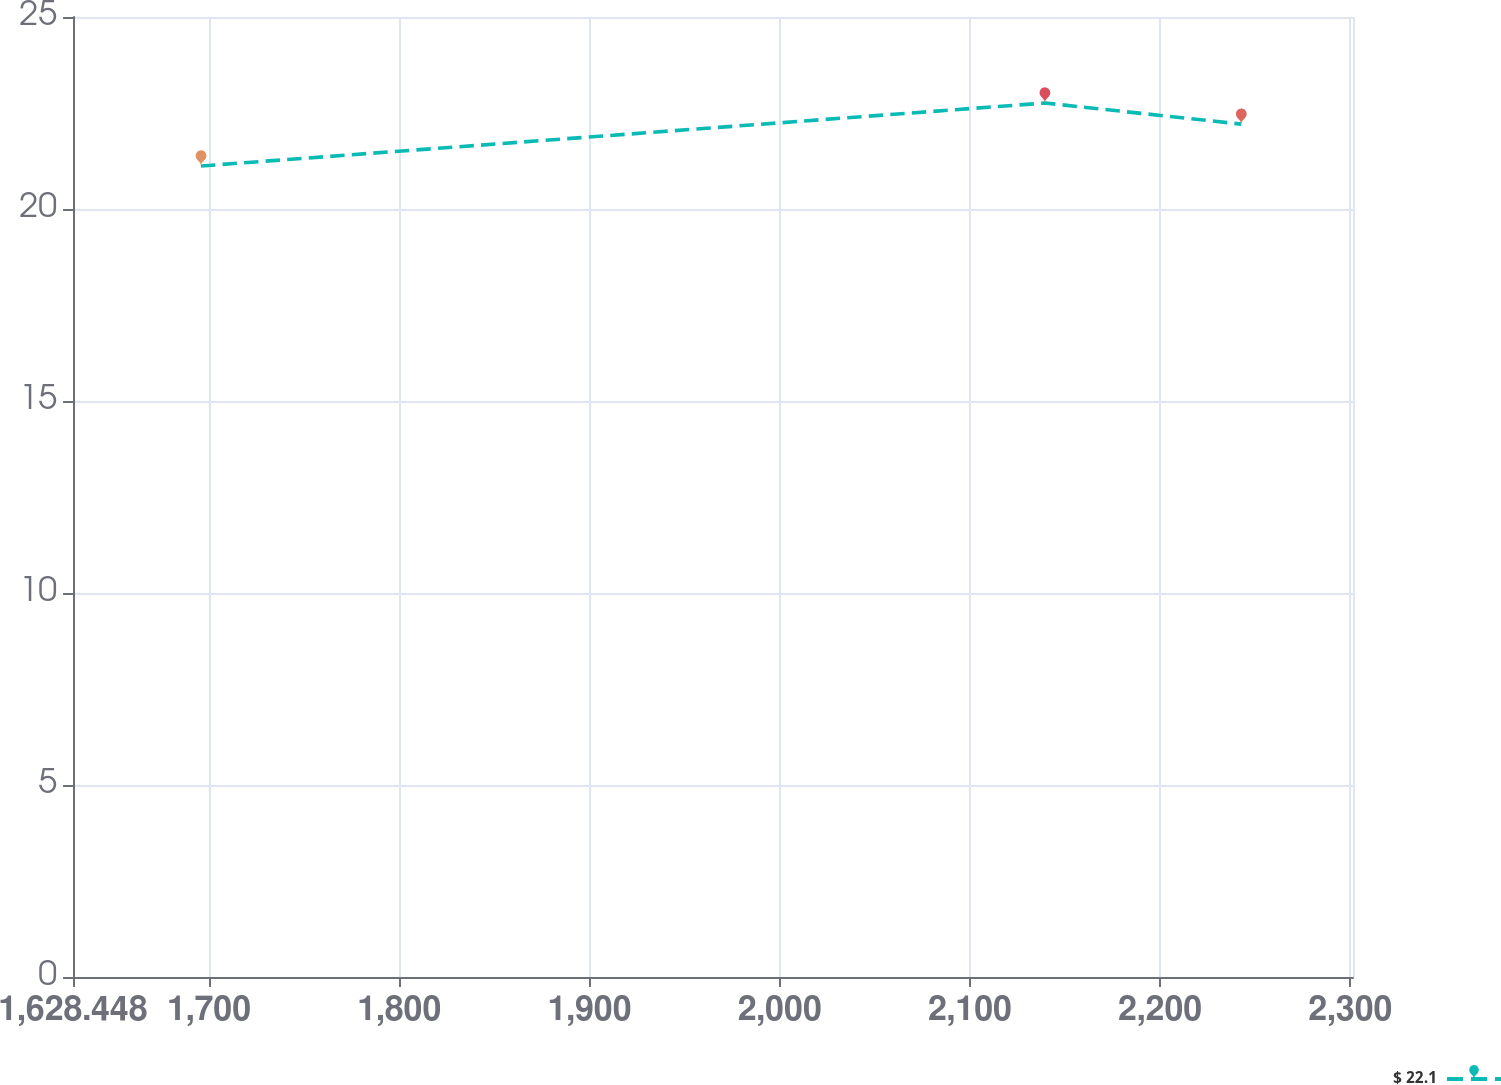Convert chart to OTSL. <chart><loc_0><loc_0><loc_500><loc_500><line_chart><ecel><fcel>$ 22.1<nl><fcel>1695.74<fcel>21.12<nl><fcel>2139.41<fcel>22.76<nl><fcel>2242.63<fcel>22.21<nl><fcel>2368.66<fcel>16.89<nl></chart> 